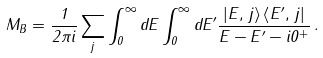Convert formula to latex. <formula><loc_0><loc_0><loc_500><loc_500>M _ { B } = \frac { 1 } { 2 \pi i } \sum _ { j } \int _ { 0 } ^ { \infty } d E \int _ { 0 } ^ { \infty } d E ^ { \prime } \frac { \left | E , \, j \right \rangle \left \langle E ^ { \prime } , \, j \right | } { E - E ^ { \prime } - i 0 ^ { + } } \, .</formula> 